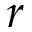<formula> <loc_0><loc_0><loc_500><loc_500>r</formula> 